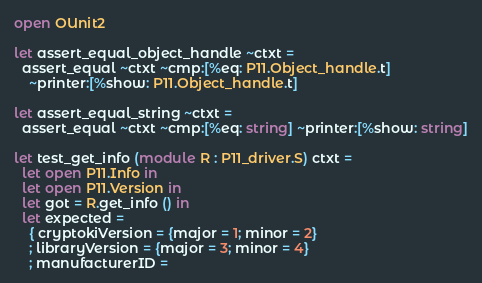<code> <loc_0><loc_0><loc_500><loc_500><_OCaml_>open OUnit2

let assert_equal_object_handle ~ctxt =
  assert_equal ~ctxt ~cmp:[%eq: P11.Object_handle.t]
    ~printer:[%show: P11.Object_handle.t]

let assert_equal_string ~ctxt =
  assert_equal ~ctxt ~cmp:[%eq: string] ~printer:[%show: string]

let test_get_info (module R : P11_driver.S) ctxt =
  let open P11.Info in
  let open P11.Version in
  let got = R.get_info () in
  let expected =
    { cryptokiVersion = {major = 1; minor = 2}
    ; libraryVersion = {major = 3; minor = 4}
    ; manufacturerID =</code> 